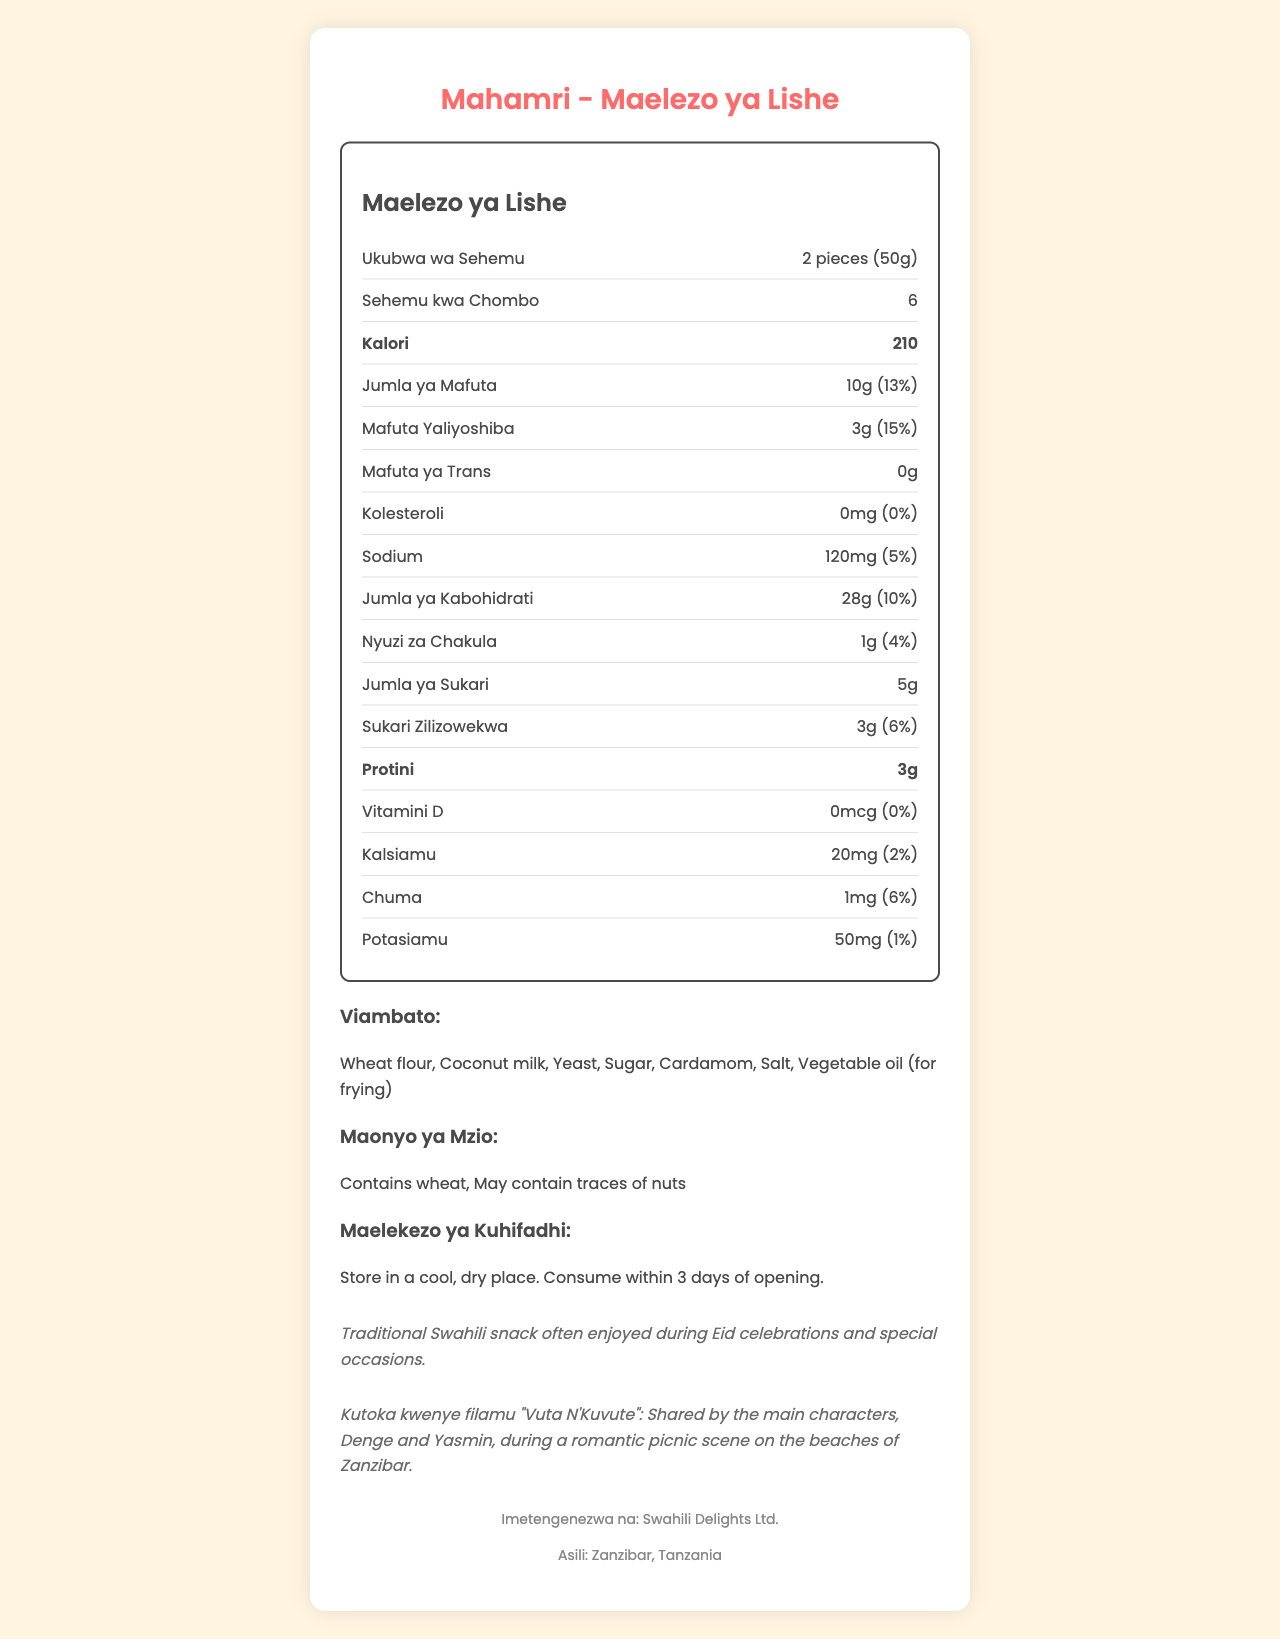What is the serving size for Mahamri? The serving size of Mahamri is listed as "2 pieces (50g)" in the nutrition label.
Answer: 2 pieces (50g) How many calories are there per serving of Mahamri? The document specifies that each serving of Mahamri contains 210 calories.
Answer: 210 What is the total fat content in one serving of Mahamri? The nutrition label states that the total fat content per serving is 10g.
Answer: 10g What is the percentage of daily value for saturated fat in a serving? Under the saturated fat section, it shows that it provides 15% of the daily value.
Answer: 15% Name two main ingredients in Mahamri. The ingredients section lists "Wheat flour" and "Coconut milk" as two of the main ingredients.
Answer: Wheat flour, Coconut milk What allergens are present in Mahamri? A. Dairy B. Wheat C. Soy D. Eggs The allergen section mentions that Mahamri contains wheat and may contain traces of nuts.
Answer: B How many grams of sugar are added to Mahamri? Under the added sugars section, it states that there are 3 grams of added sugars.
Answer: 3g What is the source of this traditional Swahili snack, Mahamri? A. Kenya B. Tanzania C. Uganda The document states the origin of Mahamri is "Zanzibar, Tanzania."
Answer: B What is the potassium content in a serving of Mahamri? The nutrition information lists the potassium content as 50mg per serving.
Answer: 50mg Is Mahamri free of cholesterol? The label indicates that the cholesterol content is 0mg, which means it is free of cholesterol.
Answer: Yes Summarize the main idea of the document. The document includes a comprehensive overview of the nutritional content and ingredients of Mahamri, touches on its cultural importance, its role in a romantic film, and provides practical information like storage instructions.
Answer: The document provides the nutrition facts for a traditional Swahili snack called Mahamri, which is featured in the romantic film "Vuta N'Kuvute". It includes information on calories, fats, carbohydrates, proteins, vitamins, minerals, ingredients, allergens, storage instructions, cultural significance, and the context within the film where it is shared by the main characters during a romantic picnic on the beaches of Zanzibar. It also mentions the manufacturer and origin of the snack. What is the daily value percentage of protein in Mahamri? The document lists the protein content as 3g but does not provide a daily value percentage for protein.
Answer: Not enough information 